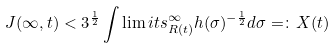<formula> <loc_0><loc_0><loc_500><loc_500>J ( \infty , t ) < 3 ^ { \frac { 1 } { 2 } } \int \lim i t s ^ { \infty } _ { R ( t ) } h ( \sigma ) ^ { - \frac { 1 } { 2 } } d \sigma = \colon X ( t )</formula> 